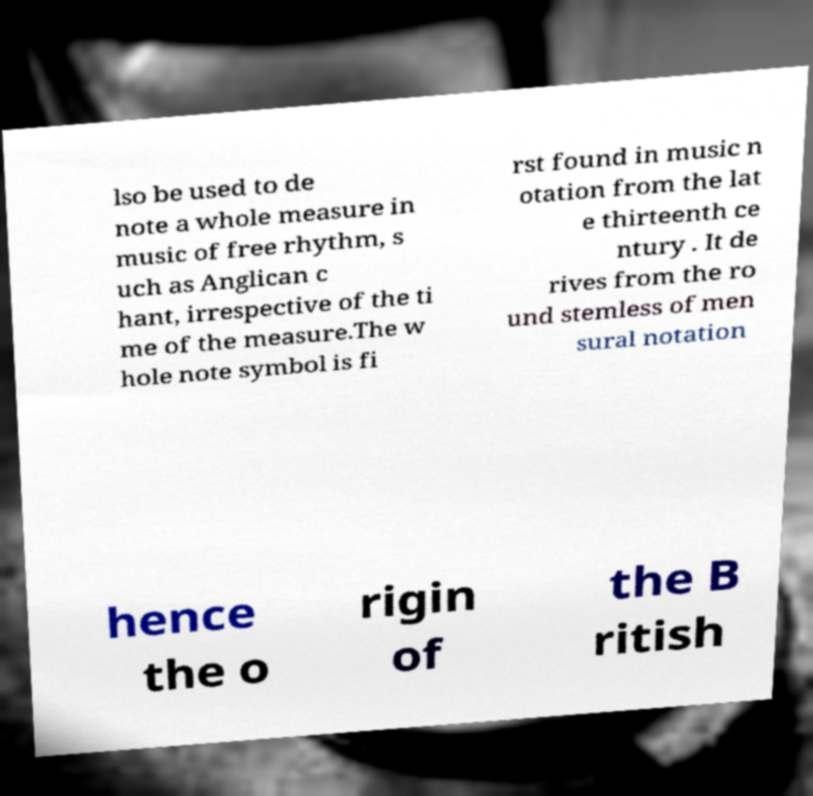Can you accurately transcribe the text from the provided image for me? lso be used to de note a whole measure in music of free rhythm, s uch as Anglican c hant, irrespective of the ti me of the measure.The w hole note symbol is fi rst found in music n otation from the lat e thirteenth ce ntury . It de rives from the ro und stemless of men sural notation hence the o rigin of the B ritish 